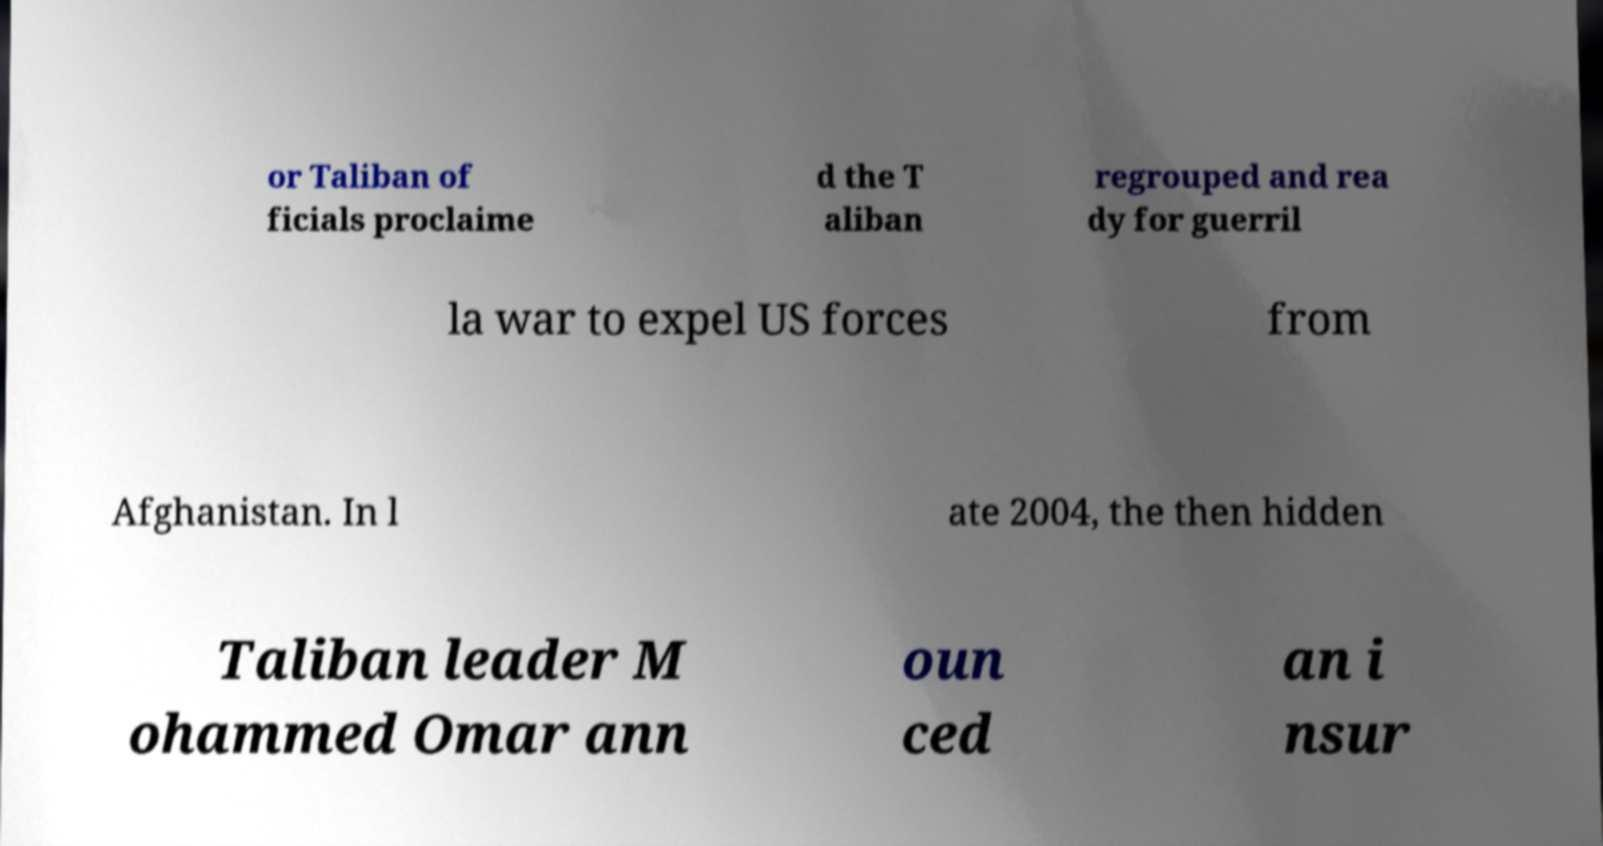Could you assist in decoding the text presented in this image and type it out clearly? or Taliban of ficials proclaime d the T aliban regrouped and rea dy for guerril la war to expel US forces from Afghanistan. In l ate 2004, the then hidden Taliban leader M ohammed Omar ann oun ced an i nsur 